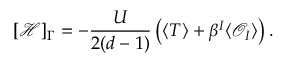<formula> <loc_0><loc_0><loc_500><loc_500>[ \mathcal { H } ] _ { \Gamma } = - \frac { U } { 2 ( d - 1 ) } \left ( \langle T \rangle + \beta ^ { I } \langle \mathcal { O } _ { I } \rangle \right ) .</formula> 